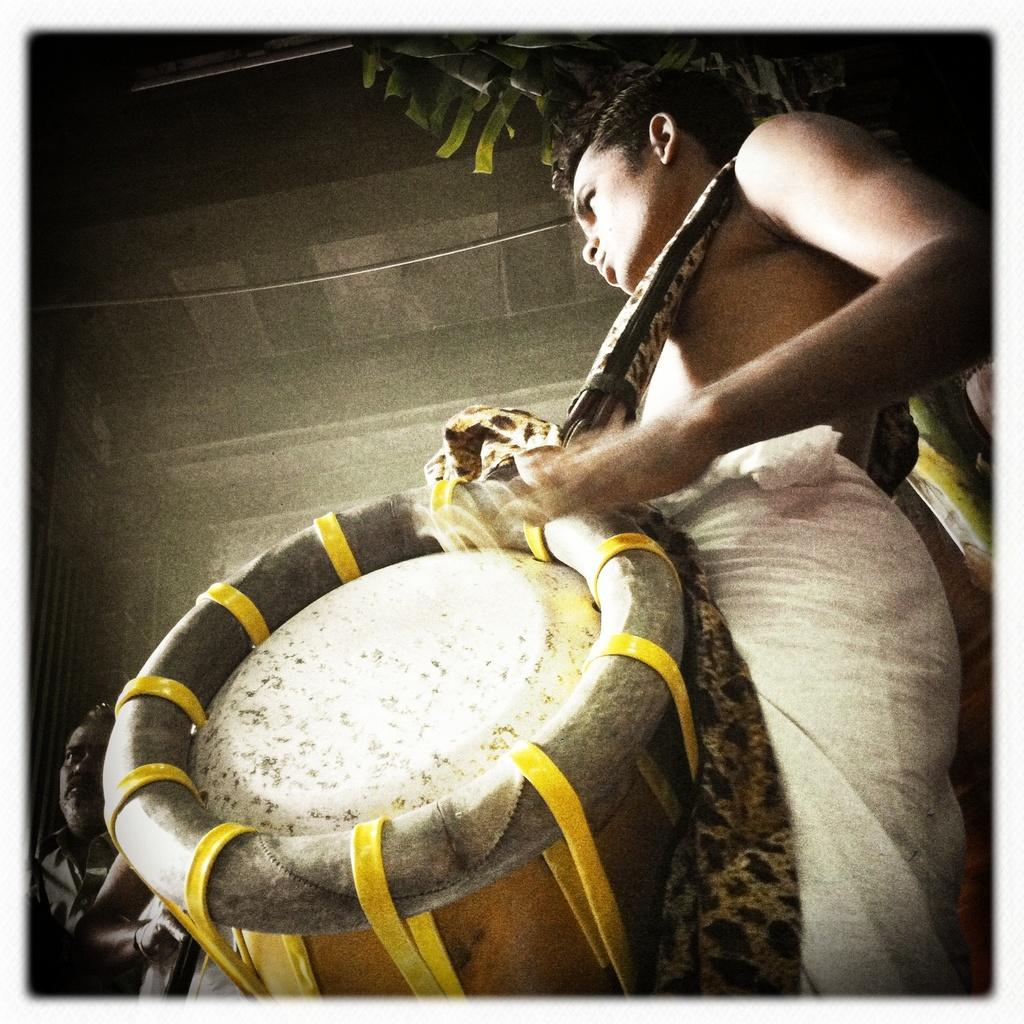What is the main subject of the image? The main subject of the image is a man. What is the man doing in the image? The man is standing and playing the tabla. What is the man wearing while playing the tabla? The man is wearing a tabla. What can be seen in the background of the image? There is a wall in the background of the image. What type of doll is sitting on the tin in the image? There is no doll or tin present in the image; it features a man playing the tabla with a wall in the background. 